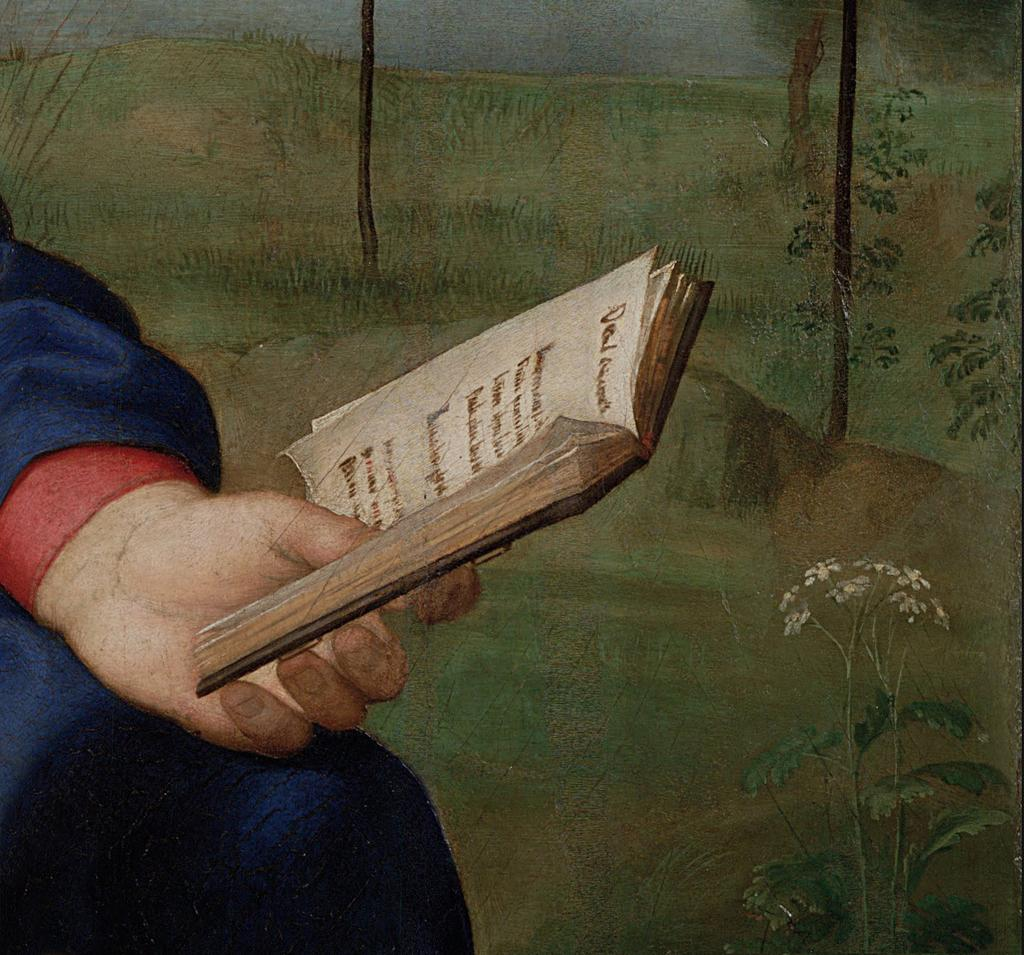What type of artwork is depicted in the image? The image is a painting. Can you describe the subject of the painting? There is a person in the painting. What is the person holding in the painting? The person is holding a book. What can be seen in the background of the painting? There are trees and plants in the background of the painting. What color is the shirt the person is wearing in the painting? There is no shirt visible in the painting; the person is holding a book. How many snakes are slithering on the floor in the painting? There are no snakes present in the painting; it features a person holding a book with trees and plants in the background. 